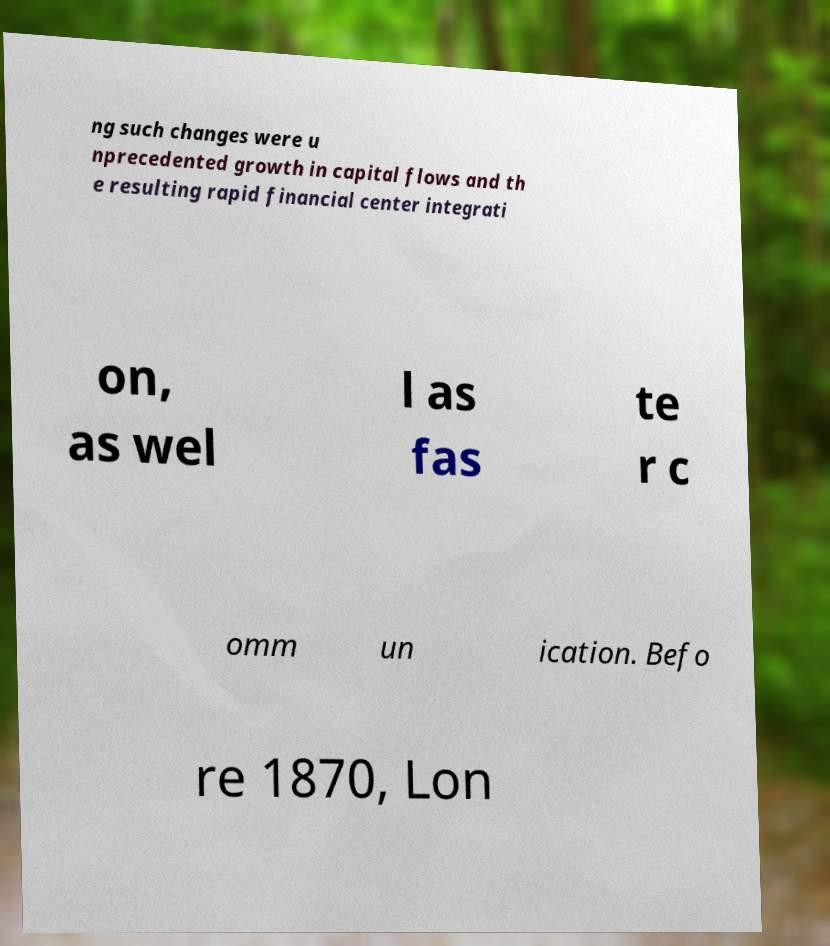I need the written content from this picture converted into text. Can you do that? ng such changes were u nprecedented growth in capital flows and th e resulting rapid financial center integrati on, as wel l as fas te r c omm un ication. Befo re 1870, Lon 